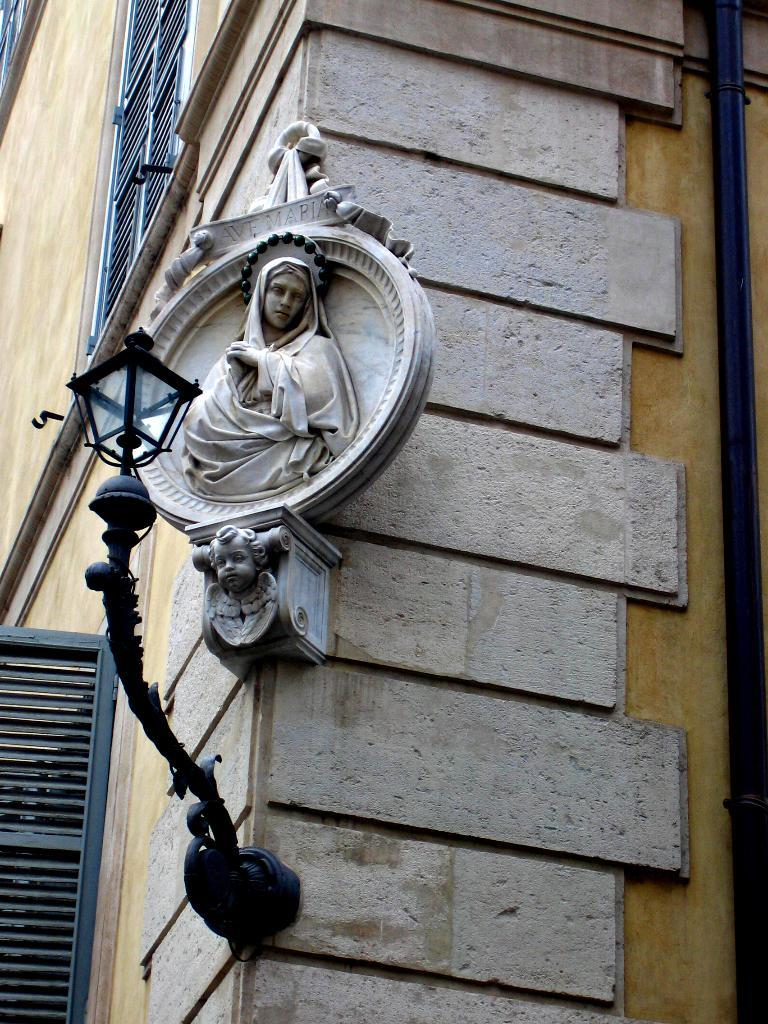What is the main structure in the image? There is a building in the image. What decorative element is present on the building? There is a sculpture on the building. Can you describe the lighting feature on the building? A light is placed on the wall at the bottom of the building. How can the interior of the building be observed? There are windows in the building. What type of voice can be heard coming from the building in the image? There is no indication of any voice or sound in the image, as it only shows a building with a sculpture, a light, and windows. 